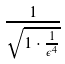<formula> <loc_0><loc_0><loc_500><loc_500>\frac { 1 } { \sqrt { 1 \cdot \frac { 1 } { \epsilon ^ { 4 } } } }</formula> 